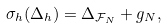Convert formula to latex. <formula><loc_0><loc_0><loc_500><loc_500>\sigma _ { h } ( \Delta _ { h } ) = \Delta _ { { \mathcal { F } } _ { N } } + g _ { N } ,</formula> 